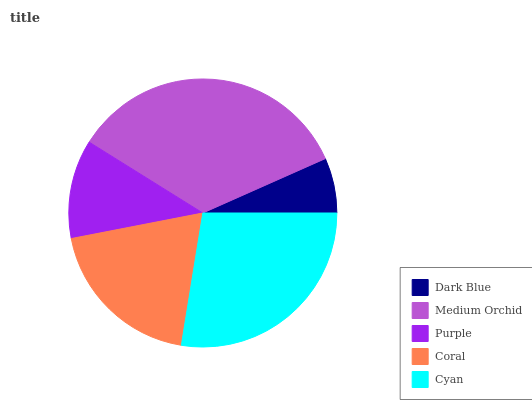Is Dark Blue the minimum?
Answer yes or no. Yes. Is Medium Orchid the maximum?
Answer yes or no. Yes. Is Purple the minimum?
Answer yes or no. No. Is Purple the maximum?
Answer yes or no. No. Is Medium Orchid greater than Purple?
Answer yes or no. Yes. Is Purple less than Medium Orchid?
Answer yes or no. Yes. Is Purple greater than Medium Orchid?
Answer yes or no. No. Is Medium Orchid less than Purple?
Answer yes or no. No. Is Coral the high median?
Answer yes or no. Yes. Is Coral the low median?
Answer yes or no. Yes. Is Dark Blue the high median?
Answer yes or no. No. Is Dark Blue the low median?
Answer yes or no. No. 